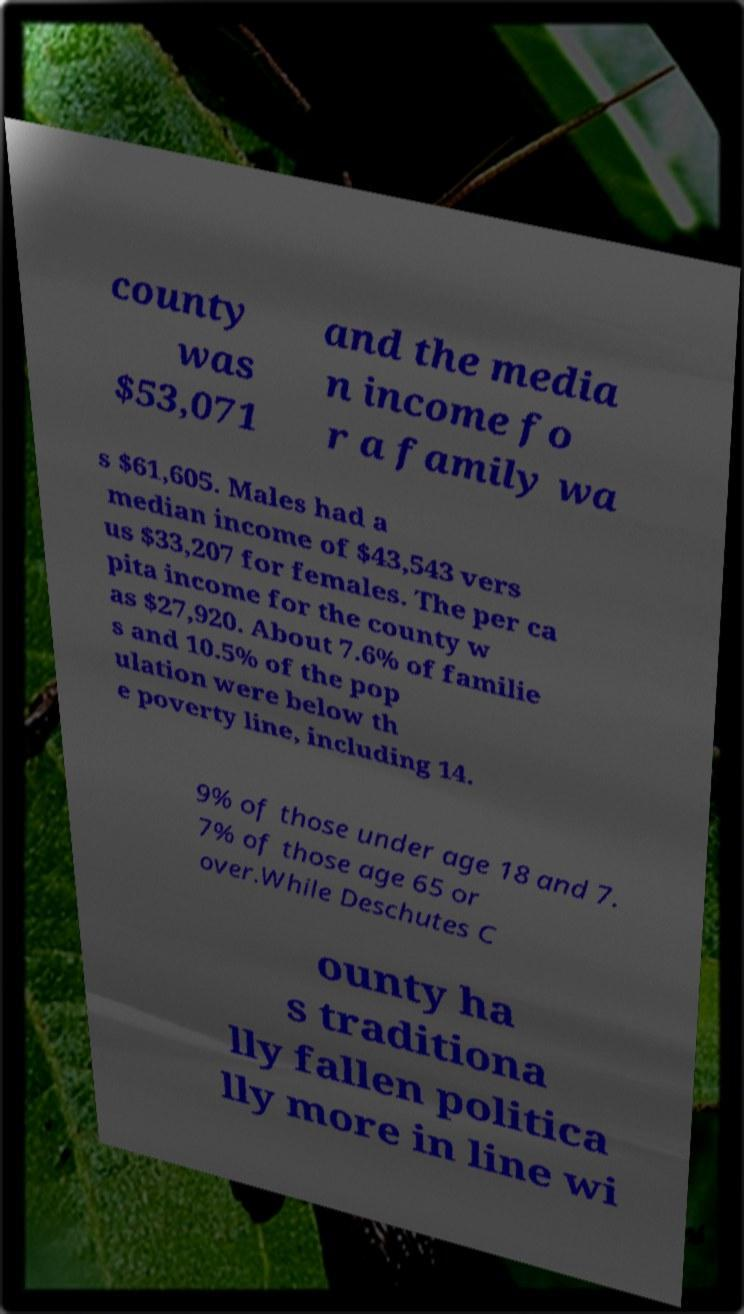Can you read and provide the text displayed in the image?This photo seems to have some interesting text. Can you extract and type it out for me? county was $53,071 and the media n income fo r a family wa s $61,605. Males had a median income of $43,543 vers us $33,207 for females. The per ca pita income for the county w as $27,920. About 7.6% of familie s and 10.5% of the pop ulation were below th e poverty line, including 14. 9% of those under age 18 and 7. 7% of those age 65 or over.While Deschutes C ounty ha s traditiona lly fallen politica lly more in line wi 